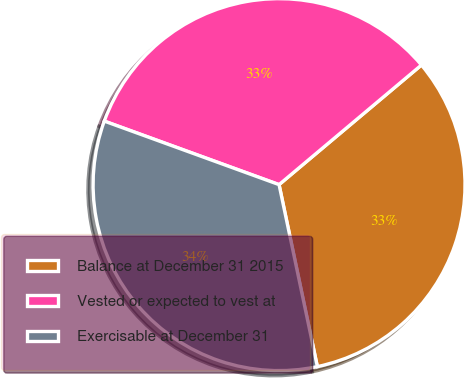Convert chart to OTSL. <chart><loc_0><loc_0><loc_500><loc_500><pie_chart><fcel>Balance at December 31 2015<fcel>Vested or expected to vest at<fcel>Exercisable at December 31<nl><fcel>32.82%<fcel>33.33%<fcel>33.85%<nl></chart> 